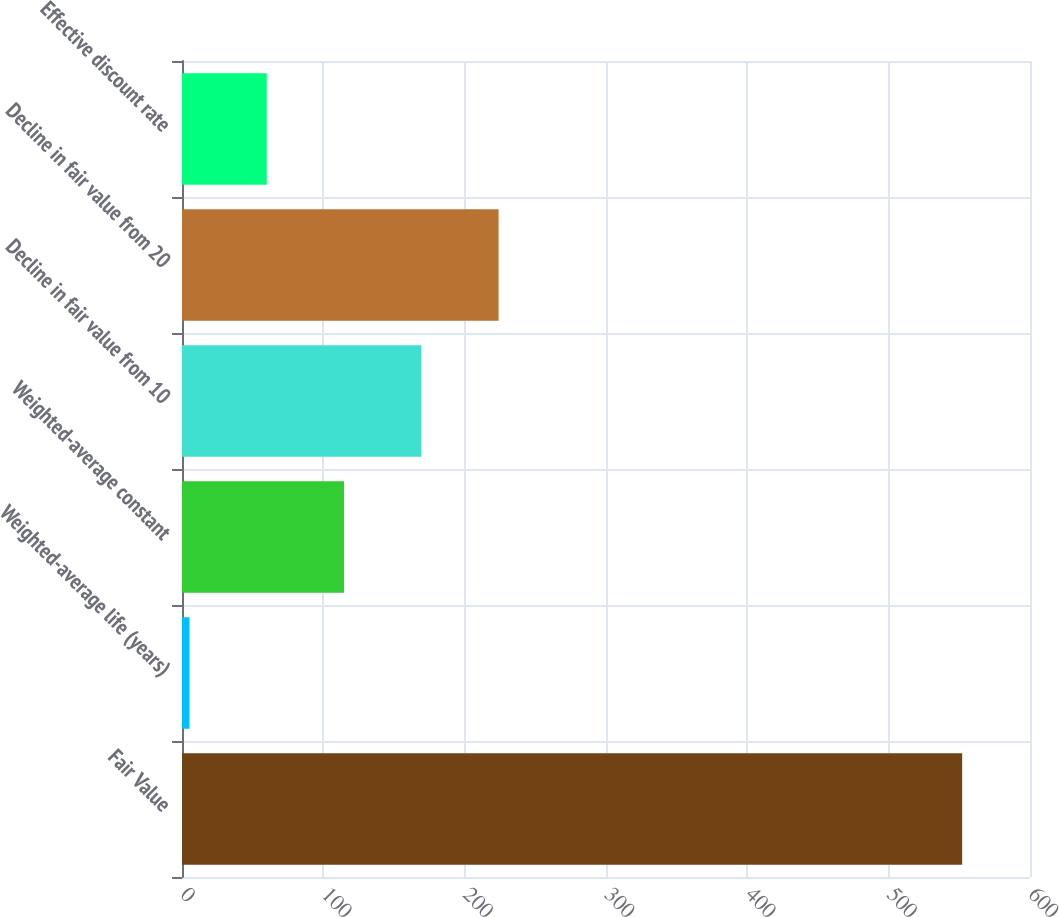Convert chart. <chart><loc_0><loc_0><loc_500><loc_500><bar_chart><fcel>Fair Value<fcel>Weighted-average life (years)<fcel>Weighted-average constant<fcel>Decline in fair value from 10<fcel>Decline in fair value from 20<fcel>Effective discount rate<nl><fcel>552<fcel>5.3<fcel>114.64<fcel>169.31<fcel>223.98<fcel>59.97<nl></chart> 